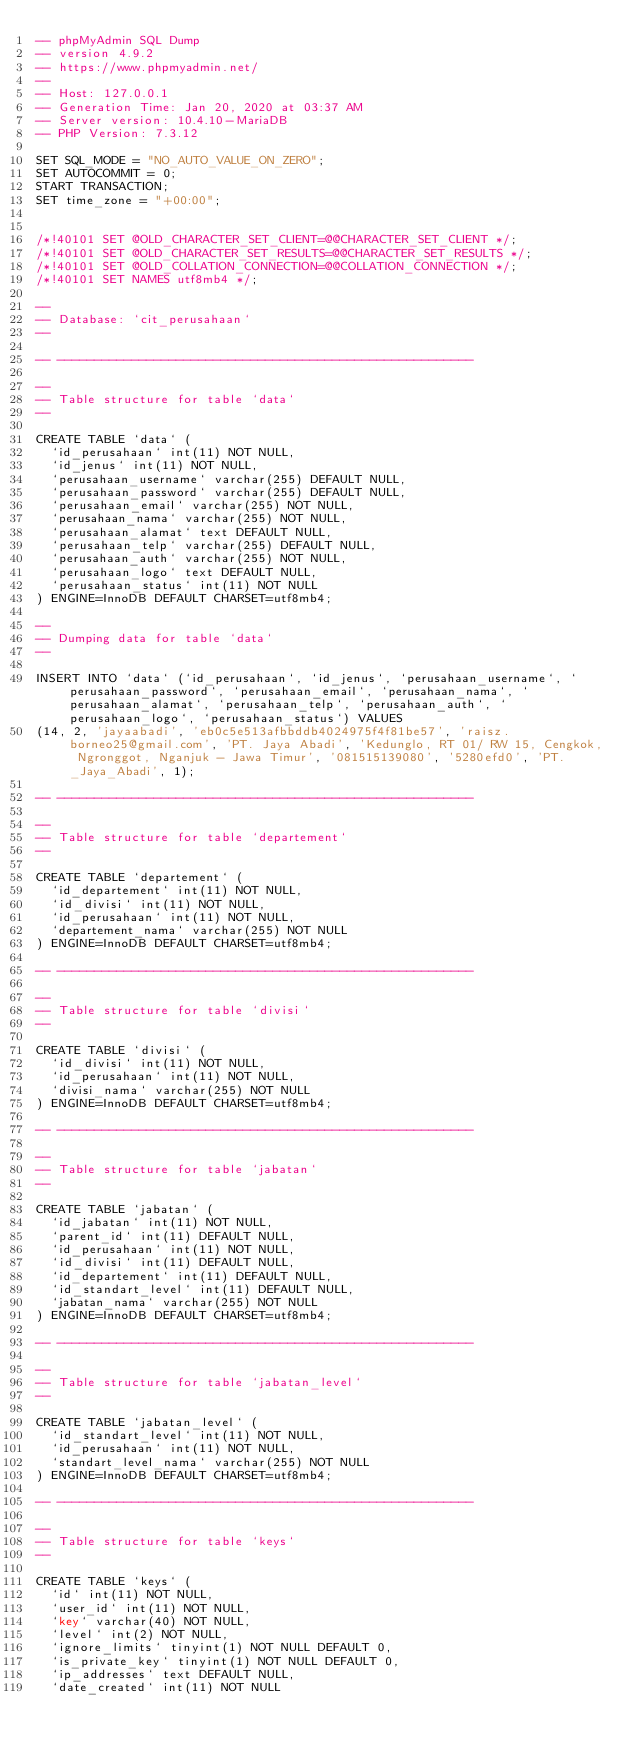<code> <loc_0><loc_0><loc_500><loc_500><_SQL_>-- phpMyAdmin SQL Dump
-- version 4.9.2
-- https://www.phpmyadmin.net/
--
-- Host: 127.0.0.1
-- Generation Time: Jan 20, 2020 at 03:37 AM
-- Server version: 10.4.10-MariaDB
-- PHP Version: 7.3.12

SET SQL_MODE = "NO_AUTO_VALUE_ON_ZERO";
SET AUTOCOMMIT = 0;
START TRANSACTION;
SET time_zone = "+00:00";


/*!40101 SET @OLD_CHARACTER_SET_CLIENT=@@CHARACTER_SET_CLIENT */;
/*!40101 SET @OLD_CHARACTER_SET_RESULTS=@@CHARACTER_SET_RESULTS */;
/*!40101 SET @OLD_COLLATION_CONNECTION=@@COLLATION_CONNECTION */;
/*!40101 SET NAMES utf8mb4 */;

--
-- Database: `cit_perusahaan`
--

-- --------------------------------------------------------

--
-- Table structure for table `data`
--

CREATE TABLE `data` (
  `id_perusahaan` int(11) NOT NULL,
  `id_jenus` int(11) NOT NULL,
  `perusahaan_username` varchar(255) DEFAULT NULL,
  `perusahaan_password` varchar(255) DEFAULT NULL,
  `perusahaan_email` varchar(255) NOT NULL,
  `perusahaan_nama` varchar(255) NOT NULL,
  `perusahaan_alamat` text DEFAULT NULL,
  `perusahaan_telp` varchar(255) DEFAULT NULL,
  `perusahaan_auth` varchar(255) NOT NULL,
  `perusahaan_logo` text DEFAULT NULL,
  `perusahaan_status` int(11) NOT NULL
) ENGINE=InnoDB DEFAULT CHARSET=utf8mb4;

--
-- Dumping data for table `data`
--

INSERT INTO `data` (`id_perusahaan`, `id_jenus`, `perusahaan_username`, `perusahaan_password`, `perusahaan_email`, `perusahaan_nama`, `perusahaan_alamat`, `perusahaan_telp`, `perusahaan_auth`, `perusahaan_logo`, `perusahaan_status`) VALUES
(14, 2, 'jayaabadi', 'eb0c5e513afbbddb4024975f4f81be57', 'raisz.borneo25@gmail.com', 'PT. Jaya Abadi', 'Kedunglo, RT 01/ RW 15, Cengkok, Ngronggot, Nganjuk - Jawa Timur', '081515139080', '5280efd0', 'PT._Jaya_Abadi', 1);

-- --------------------------------------------------------

--
-- Table structure for table `departement`
--

CREATE TABLE `departement` (
  `id_departement` int(11) NOT NULL,
  `id_divisi` int(11) NOT NULL,
  `id_perusahaan` int(11) NOT NULL,
  `departement_nama` varchar(255) NOT NULL
) ENGINE=InnoDB DEFAULT CHARSET=utf8mb4;

-- --------------------------------------------------------

--
-- Table structure for table `divisi`
--

CREATE TABLE `divisi` (
  `id_divisi` int(11) NOT NULL,
  `id_perusahaan` int(11) NOT NULL,
  `divisi_nama` varchar(255) NOT NULL
) ENGINE=InnoDB DEFAULT CHARSET=utf8mb4;

-- --------------------------------------------------------

--
-- Table structure for table `jabatan`
--

CREATE TABLE `jabatan` (
  `id_jabatan` int(11) NOT NULL,
  `parent_id` int(11) DEFAULT NULL,
  `id_perusahaan` int(11) NOT NULL,
  `id_divisi` int(11) DEFAULT NULL,
  `id_departement` int(11) DEFAULT NULL,
  `id_standart_level` int(11) DEFAULT NULL,
  `jabatan_nama` varchar(255) NOT NULL
) ENGINE=InnoDB DEFAULT CHARSET=utf8mb4;

-- --------------------------------------------------------

--
-- Table structure for table `jabatan_level`
--

CREATE TABLE `jabatan_level` (
  `id_standart_level` int(11) NOT NULL,
  `id_perusahaan` int(11) NOT NULL,
  `standart_level_nama` varchar(255) NOT NULL
) ENGINE=InnoDB DEFAULT CHARSET=utf8mb4;

-- --------------------------------------------------------

--
-- Table structure for table `keys`
--

CREATE TABLE `keys` (
  `id` int(11) NOT NULL,
  `user_id` int(11) NOT NULL,
  `key` varchar(40) NOT NULL,
  `level` int(2) NOT NULL,
  `ignore_limits` tinyint(1) NOT NULL DEFAULT 0,
  `is_private_key` tinyint(1) NOT NULL DEFAULT 0,
  `ip_addresses` text DEFAULT NULL,
  `date_created` int(11) NOT NULL</code> 